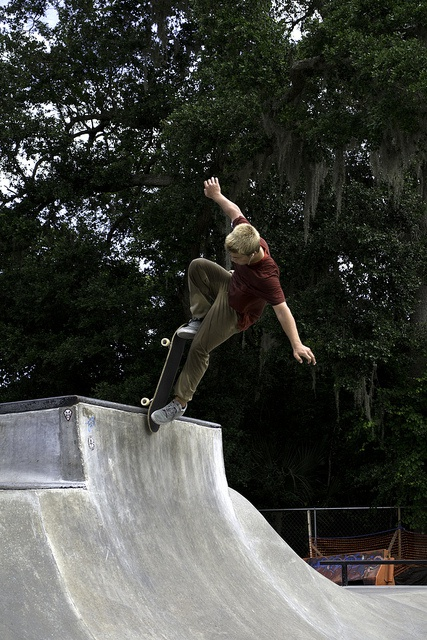Describe the objects in this image and their specific colors. I can see people in lavender, black, gray, and maroon tones and skateboard in lavender, black, gray, and darkgray tones in this image. 